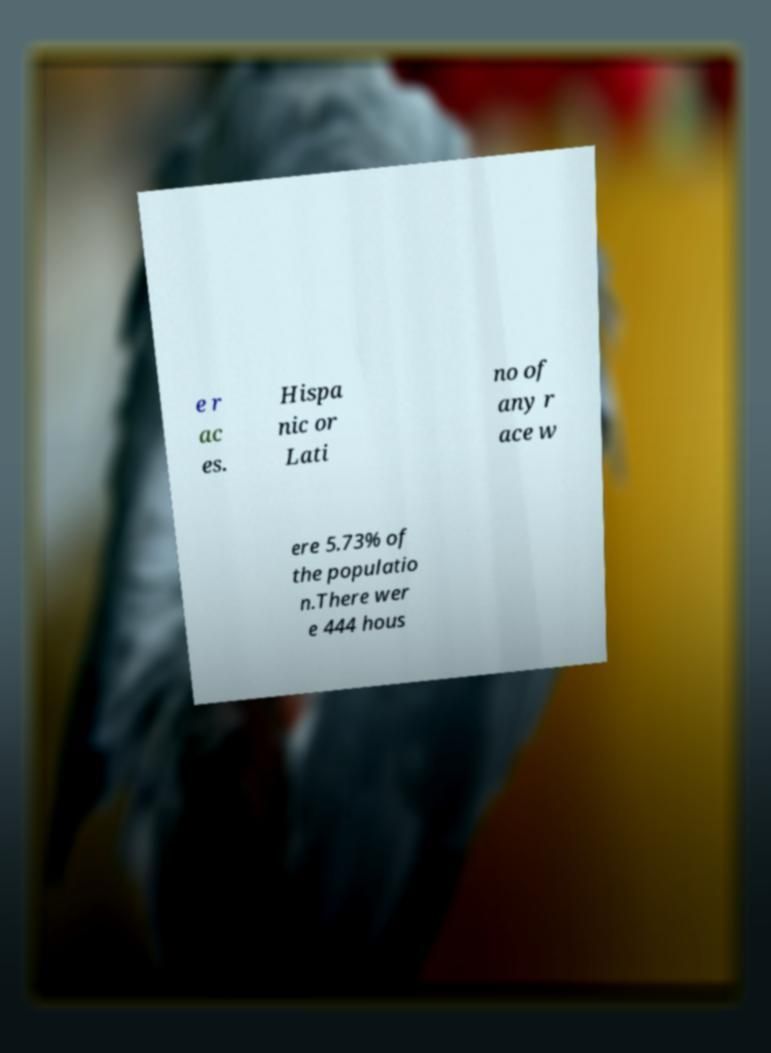There's text embedded in this image that I need extracted. Can you transcribe it verbatim? e r ac es. Hispa nic or Lati no of any r ace w ere 5.73% of the populatio n.There wer e 444 hous 